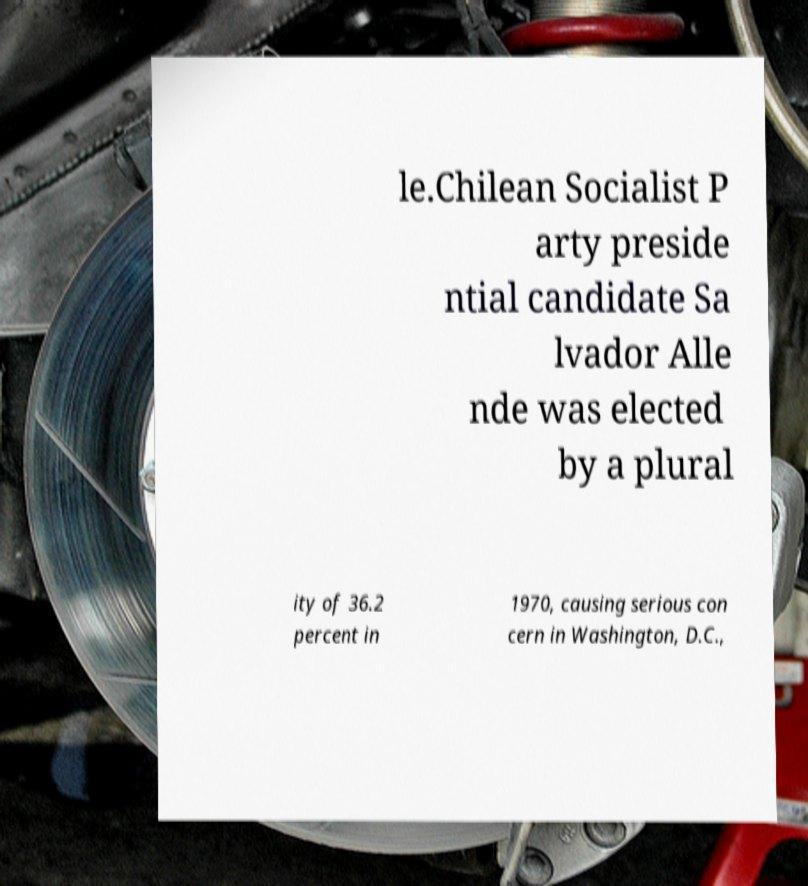What messages or text are displayed in this image? I need them in a readable, typed format. le.Chilean Socialist P arty preside ntial candidate Sa lvador Alle nde was elected by a plural ity of 36.2 percent in 1970, causing serious con cern in Washington, D.C., 